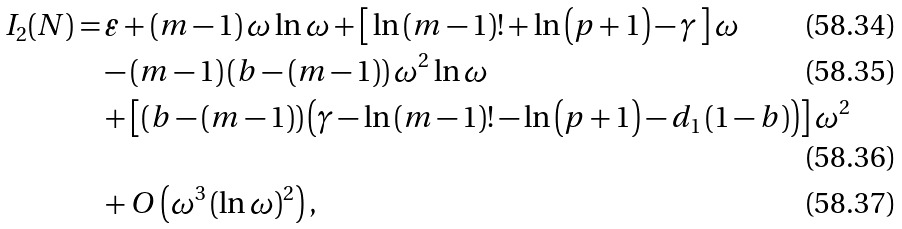Convert formula to latex. <formula><loc_0><loc_0><loc_500><loc_500>I _ { 2 } ( N ) = & \, \varepsilon + \left ( m - 1 \right ) \omega \ln \omega + \left [ \, \ln \left ( m - 1 \right ) ! + \ln \left ( p + 1 \right ) - \gamma \, \right ] \omega \\ & - \left ( m - 1 \right ) \left ( b - \left ( m - 1 \right ) \right ) \omega ^ { 2 } \ln \omega \\ & + \left [ \left ( b - \left ( m - 1 \right ) \right ) \left ( \gamma - \ln \left ( m - 1 \right ) ! - \ln \left ( p + 1 \right ) - d _ { 1 } \left ( 1 - b \right ) \right ) \right ] \omega ^ { 2 } \\ & + O \left ( \omega ^ { 3 } \left ( \ln \omega \right ) ^ { 2 } \right ) ,</formula> 